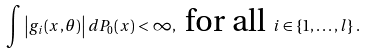Convert formula to latex. <formula><loc_0><loc_0><loc_500><loc_500>\int \left | g _ { i } ( x , \theta ) \right | d P _ { 0 } ( x ) < \infty , \text { for all } i \in \left \{ 1 , \dots , l \right \} .</formula> 